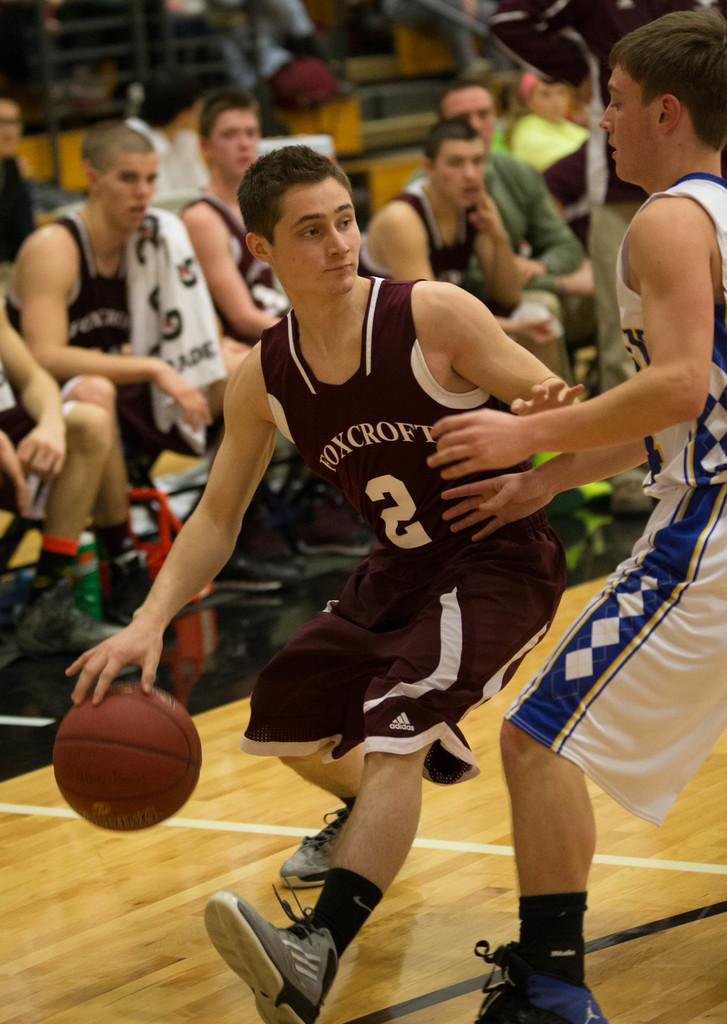How many people are in the image? There is a group of people in the image. What are two people in the group doing? Two people in the group are playing with a ball. What type of silver monkey is sitting on the owner's shoulder in the image? There is no silver monkey or owner present in the image; it only features a group of people and two of them playing with a ball. 